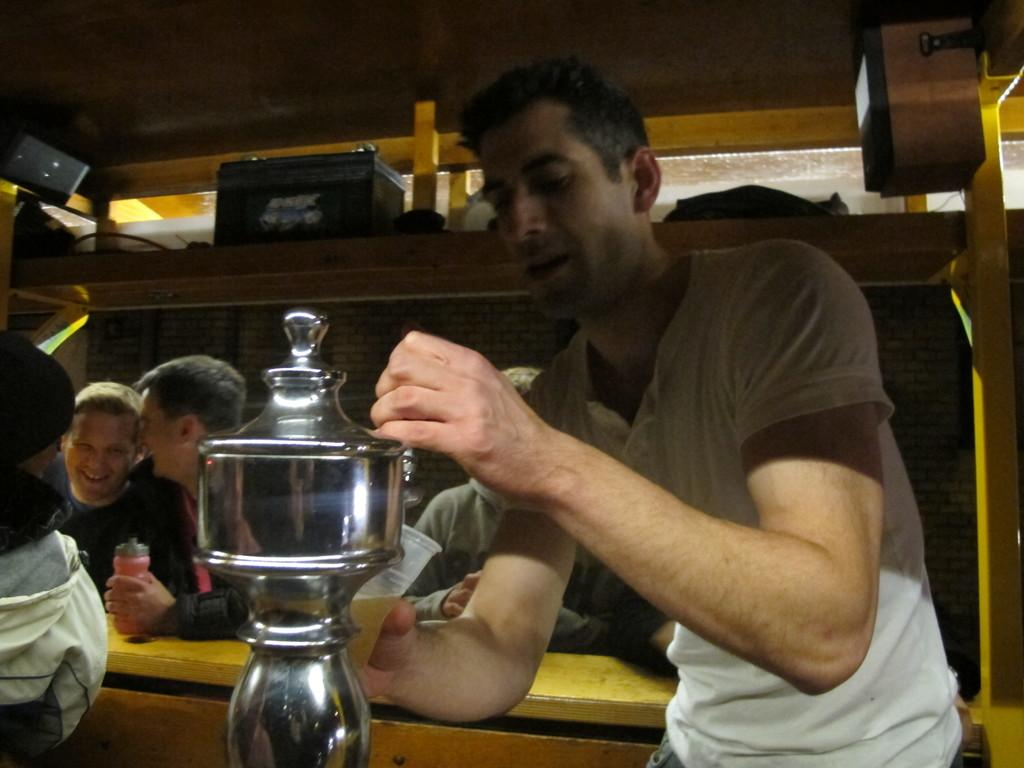How many people are in the image? There are people in the image, but the exact number is not specified. What is the man holding in the image? The man is holding an object in the image. What type of shelf is visible in the image? There is a wooden shelf visible in the image. Can you describe the object on the right side of the image? There is an object on the right side of the image, but its specific nature is not mentioned. Is the man performing magic with the object he is holding in the image? There is no indication in the image that the man is performing magic with the object he is holding. Can you tell me how many toothbrushes are on the wooden shelf in the image? There is no mention of toothbrushes in the image or the facts provided. 